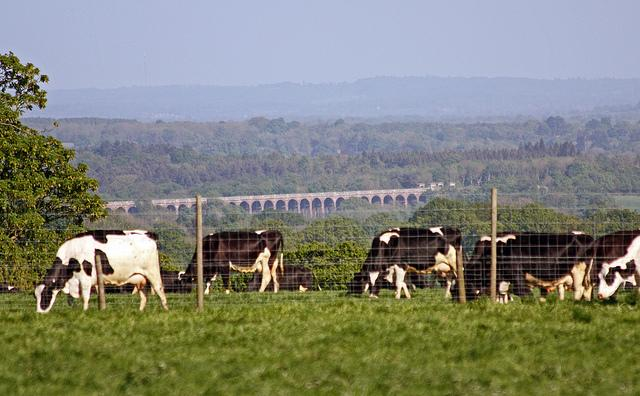The cow belongs to which genus?

Choices:
A) bovinae
B) bovidae
C) bos
D) cattle bos 